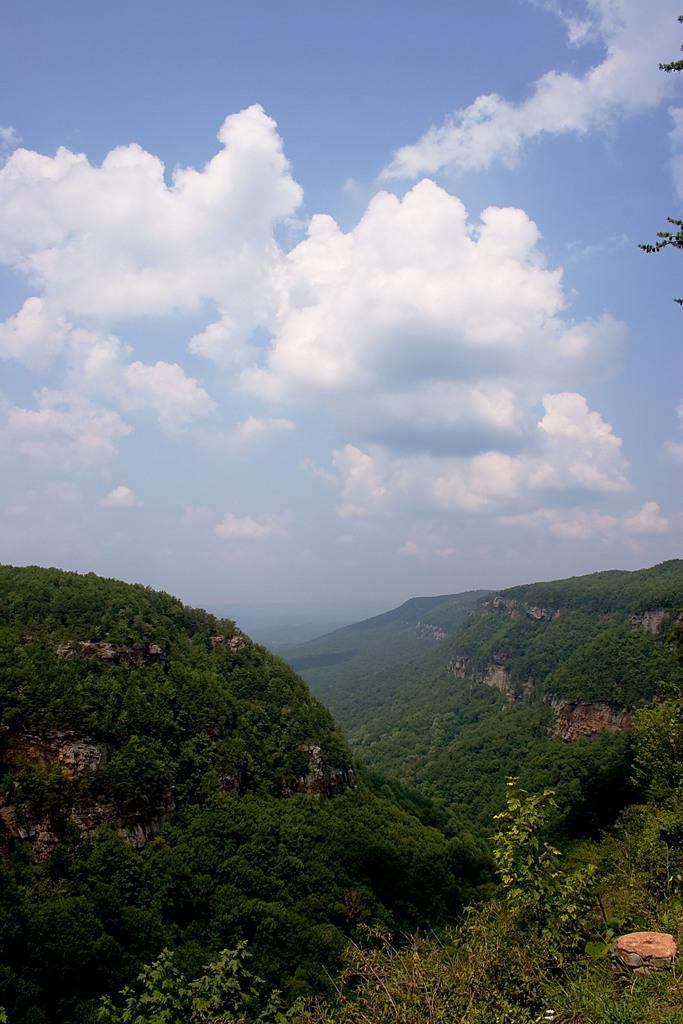What type of natural features can be seen in the image? There are trees and mountains in the image. What part of the natural environment is visible in the image? The sky is visible in the image. Can you describe the setting where the image might have been taken? The image may have been taken near the mountains, given their prominence in the image. What type of oatmeal is being served in the image? There is no oatmeal present in the image; it features trees, mountains, and the sky. Can you see a monkey climbing one of the trees in the image? There is no monkey present in the image; it only features trees, mountains, and the sky. 